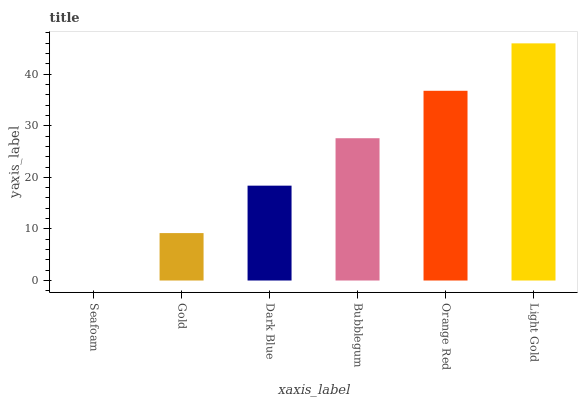Is Seafoam the minimum?
Answer yes or no. Yes. Is Light Gold the maximum?
Answer yes or no. Yes. Is Gold the minimum?
Answer yes or no. No. Is Gold the maximum?
Answer yes or no. No. Is Gold greater than Seafoam?
Answer yes or no. Yes. Is Seafoam less than Gold?
Answer yes or no. Yes. Is Seafoam greater than Gold?
Answer yes or no. No. Is Gold less than Seafoam?
Answer yes or no. No. Is Bubblegum the high median?
Answer yes or no. Yes. Is Dark Blue the low median?
Answer yes or no. Yes. Is Seafoam the high median?
Answer yes or no. No. Is Orange Red the low median?
Answer yes or no. No. 